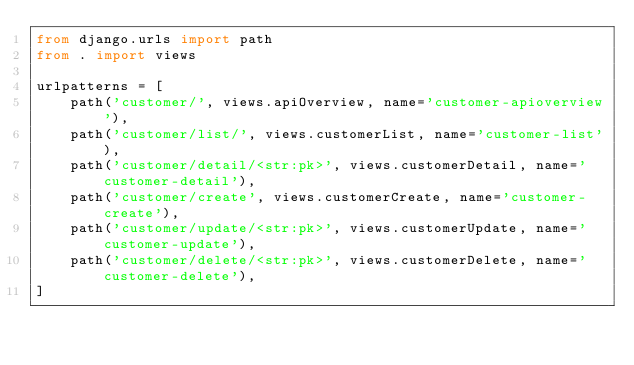<code> <loc_0><loc_0><loc_500><loc_500><_Python_>from django.urls import path
from . import views

urlpatterns = [
    path('customer/', views.apiOverview, name='customer-apioverview'),
    path('customer/list/', views.customerList, name='customer-list'),
    path('customer/detail/<str:pk>', views.customerDetail, name='customer-detail'),
    path('customer/create', views.customerCreate, name='customer-create'),
    path('customer/update/<str:pk>', views.customerUpdate, name='customer-update'),
    path('customer/delete/<str:pk>', views.customerDelete, name='customer-delete'),
]</code> 